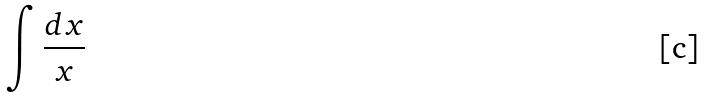Convert formula to latex. <formula><loc_0><loc_0><loc_500><loc_500>\int \frac { d x } { x }</formula> 